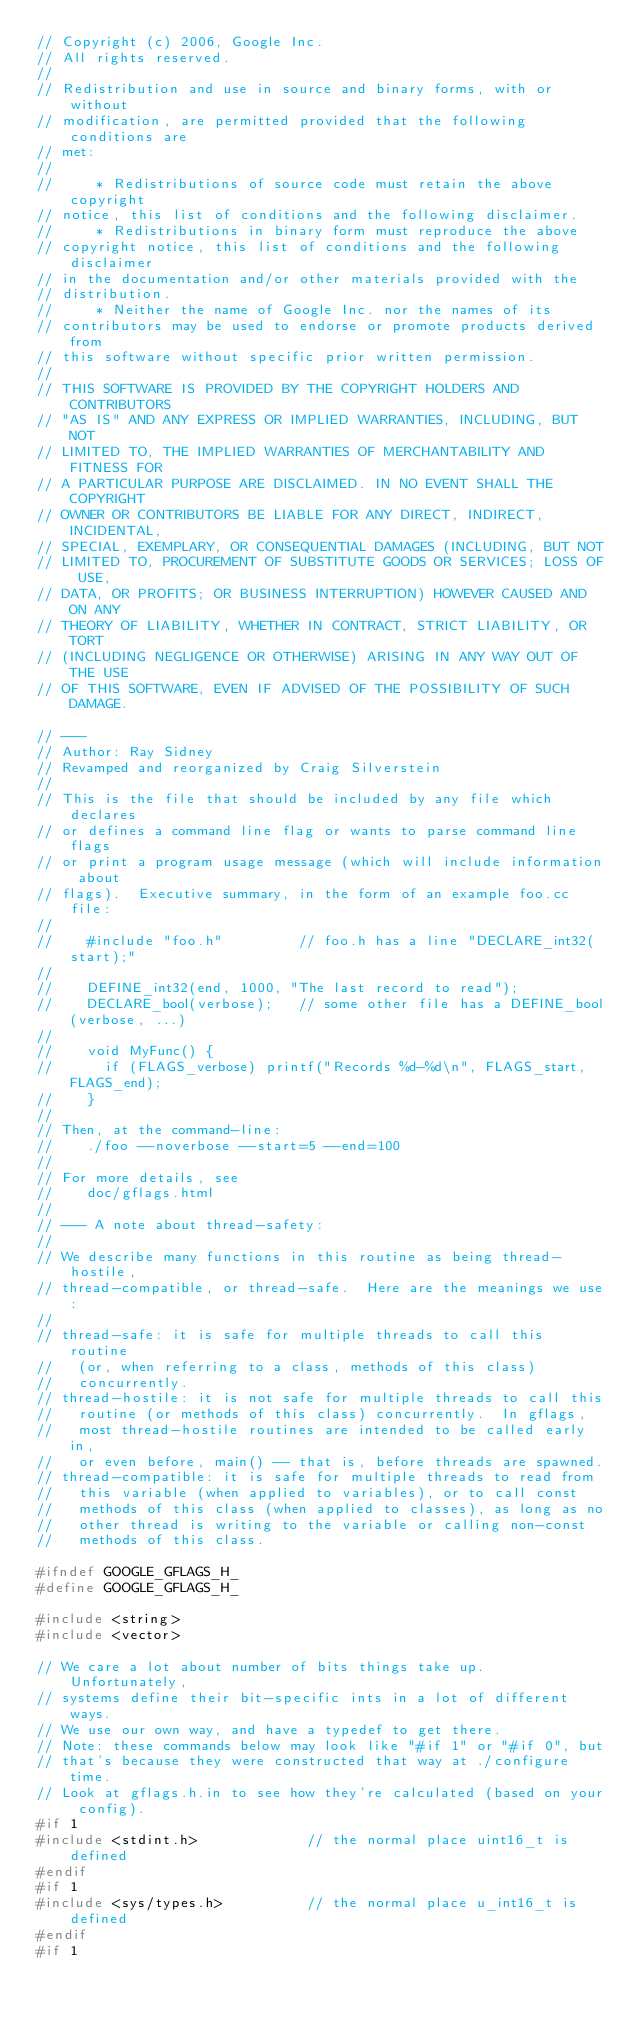Convert code to text. <code><loc_0><loc_0><loc_500><loc_500><_C_>// Copyright (c) 2006, Google Inc.
// All rights reserved.
//
// Redistribution and use in source and binary forms, with or without
// modification, are permitted provided that the following conditions are
// met:
//
//     * Redistributions of source code must retain the above copyright
// notice, this list of conditions and the following disclaimer.
//     * Redistributions in binary form must reproduce the above
// copyright notice, this list of conditions and the following disclaimer
// in the documentation and/or other materials provided with the
// distribution.
//     * Neither the name of Google Inc. nor the names of its
// contributors may be used to endorse or promote products derived from
// this software without specific prior written permission.
//
// THIS SOFTWARE IS PROVIDED BY THE COPYRIGHT HOLDERS AND CONTRIBUTORS
// "AS IS" AND ANY EXPRESS OR IMPLIED WARRANTIES, INCLUDING, BUT NOT
// LIMITED TO, THE IMPLIED WARRANTIES OF MERCHANTABILITY AND FITNESS FOR
// A PARTICULAR PURPOSE ARE DISCLAIMED. IN NO EVENT SHALL THE COPYRIGHT
// OWNER OR CONTRIBUTORS BE LIABLE FOR ANY DIRECT, INDIRECT, INCIDENTAL,
// SPECIAL, EXEMPLARY, OR CONSEQUENTIAL DAMAGES (INCLUDING, BUT NOT
// LIMITED TO, PROCUREMENT OF SUBSTITUTE GOODS OR SERVICES; LOSS OF USE,
// DATA, OR PROFITS; OR BUSINESS INTERRUPTION) HOWEVER CAUSED AND ON ANY
// THEORY OF LIABILITY, WHETHER IN CONTRACT, STRICT LIABILITY, OR TORT
// (INCLUDING NEGLIGENCE OR OTHERWISE) ARISING IN ANY WAY OUT OF THE USE
// OF THIS SOFTWARE, EVEN IF ADVISED OF THE POSSIBILITY OF SUCH DAMAGE.

// ---
// Author: Ray Sidney
// Revamped and reorganized by Craig Silverstein
//
// This is the file that should be included by any file which declares
// or defines a command line flag or wants to parse command line flags
// or print a program usage message (which will include information about
// flags).  Executive summary, in the form of an example foo.cc file:
//
//    #include "foo.h"         // foo.h has a line "DECLARE_int32(start);"
//
//    DEFINE_int32(end, 1000, "The last record to read");
//    DECLARE_bool(verbose);   // some other file has a DEFINE_bool(verbose, ...)
//
//    void MyFunc() {
//      if (FLAGS_verbose) printf("Records %d-%d\n", FLAGS_start, FLAGS_end);
//    }
//
// Then, at the command-line:
//    ./foo --noverbose --start=5 --end=100
//
// For more details, see
//    doc/gflags.html
//
// --- A note about thread-safety:
//
// We describe many functions in this routine as being thread-hostile,
// thread-compatible, or thread-safe.  Here are the meanings we use:
//
// thread-safe: it is safe for multiple threads to call this routine
//   (or, when referring to a class, methods of this class)
//   concurrently.
// thread-hostile: it is not safe for multiple threads to call this
//   routine (or methods of this class) concurrently.  In gflags,
//   most thread-hostile routines are intended to be called early in,
//   or even before, main() -- that is, before threads are spawned.
// thread-compatible: it is safe for multiple threads to read from
//   this variable (when applied to variables), or to call const
//   methods of this class (when applied to classes), as long as no
//   other thread is writing to the variable or calling non-const
//   methods of this class.

#ifndef GOOGLE_GFLAGS_H_
#define GOOGLE_GFLAGS_H_

#include <string>
#include <vector>

// We care a lot about number of bits things take up.  Unfortunately,
// systems define their bit-specific ints in a lot of different ways.
// We use our own way, and have a typedef to get there.
// Note: these commands below may look like "#if 1" or "#if 0", but
// that's because they were constructed that way at ./configure time.
// Look at gflags.h.in to see how they're calculated (based on your config).
#if 1
#include <stdint.h>             // the normal place uint16_t is defined
#endif
#if 1
#include <sys/types.h>          // the normal place u_int16_t is defined
#endif
#if 1</code> 